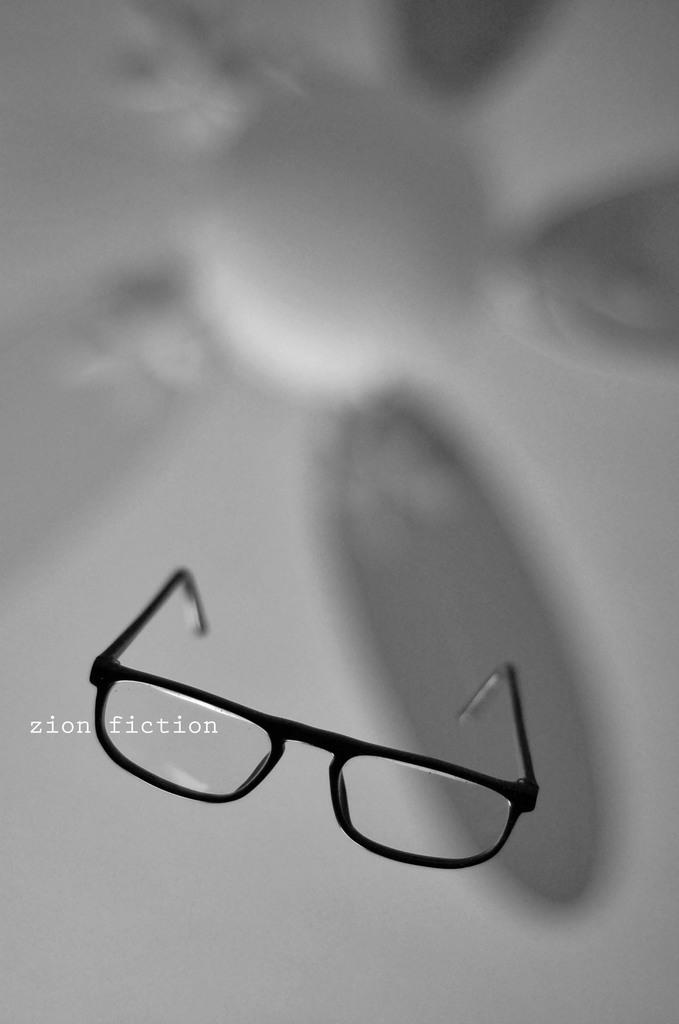What object can be seen in the image? There are spectacles in the image. Can you describe the background of the image? The background of the image is blurry. What suggestion can be made to improve the spectacles in the image? There is no need to make a suggestion to improve the spectacles in the image, as they are not real and cannot be improved. 